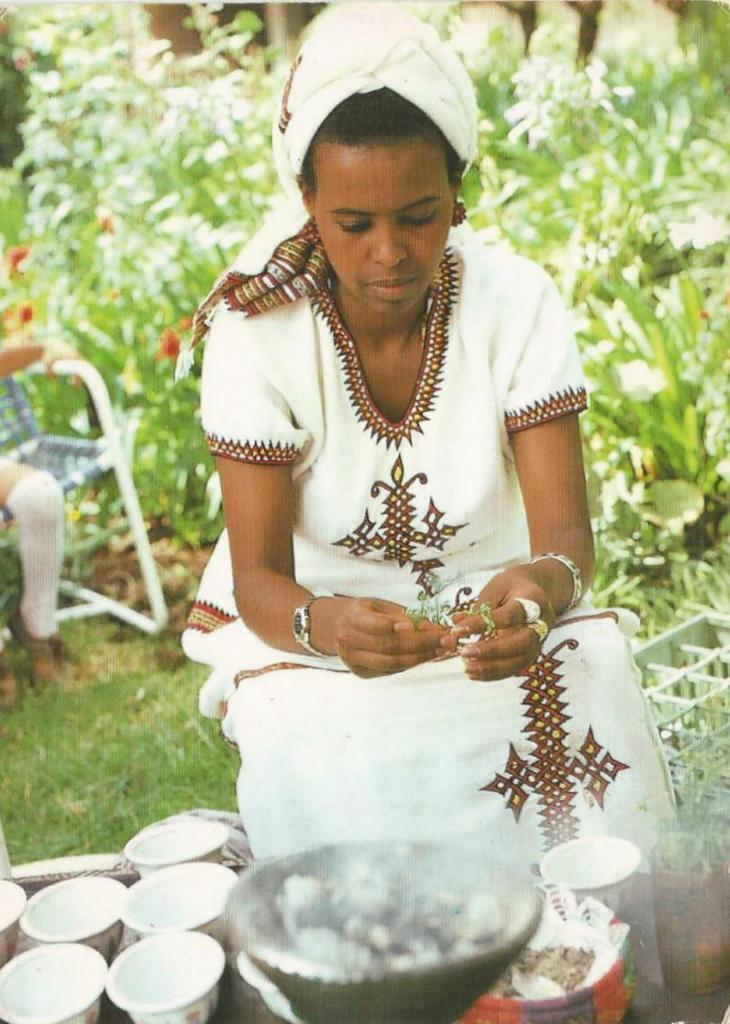Please provide a concise description of this image. In this image, we can see a person wearing clothes. There are bowls at the bottom of the image. There is a person on the chair which is on the left side of the image. In the background, we can see some plants. 